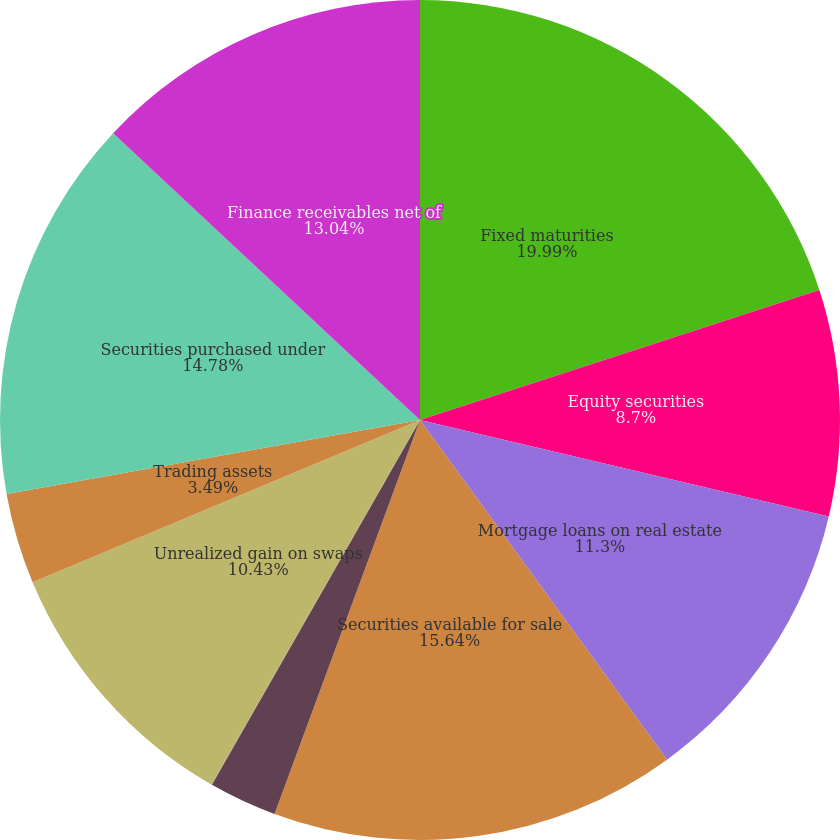Convert chart. <chart><loc_0><loc_0><loc_500><loc_500><pie_chart><fcel>Fixed maturities<fcel>Equity securities<fcel>Mortgage loans on real estate<fcel>Securities available for sale<fcel>Trading securities<fcel>Spot commodities<fcel>Unrealized gain on swaps<fcel>Trading assets<fcel>Securities purchased under<fcel>Finance receivables net of<nl><fcel>19.99%<fcel>8.7%<fcel>11.3%<fcel>15.64%<fcel>2.62%<fcel>0.01%<fcel>10.43%<fcel>3.49%<fcel>14.78%<fcel>13.04%<nl></chart> 